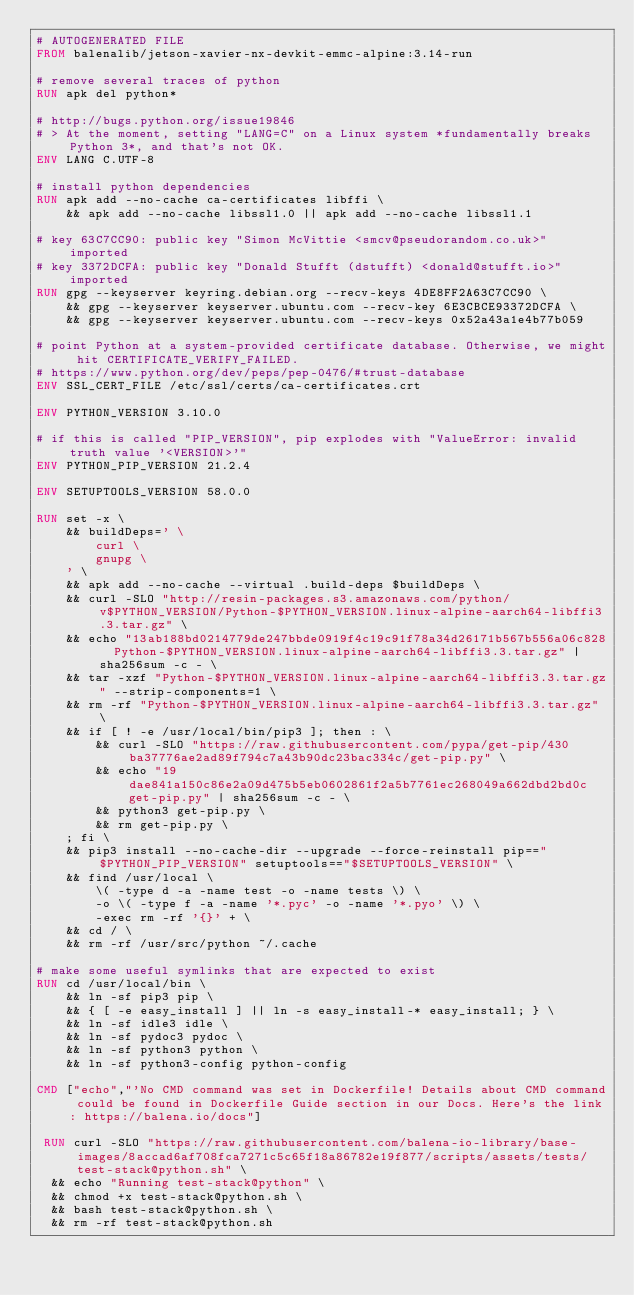Convert code to text. <code><loc_0><loc_0><loc_500><loc_500><_Dockerfile_># AUTOGENERATED FILE
FROM balenalib/jetson-xavier-nx-devkit-emmc-alpine:3.14-run

# remove several traces of python
RUN apk del python*

# http://bugs.python.org/issue19846
# > At the moment, setting "LANG=C" on a Linux system *fundamentally breaks Python 3*, and that's not OK.
ENV LANG C.UTF-8

# install python dependencies
RUN apk add --no-cache ca-certificates libffi \
	&& apk add --no-cache libssl1.0 || apk add --no-cache libssl1.1

# key 63C7CC90: public key "Simon McVittie <smcv@pseudorandom.co.uk>" imported
# key 3372DCFA: public key "Donald Stufft (dstufft) <donald@stufft.io>" imported
RUN gpg --keyserver keyring.debian.org --recv-keys 4DE8FF2A63C7CC90 \
	&& gpg --keyserver keyserver.ubuntu.com --recv-key 6E3CBCE93372DCFA \
	&& gpg --keyserver keyserver.ubuntu.com --recv-keys 0x52a43a1e4b77b059

# point Python at a system-provided certificate database. Otherwise, we might hit CERTIFICATE_VERIFY_FAILED.
# https://www.python.org/dev/peps/pep-0476/#trust-database
ENV SSL_CERT_FILE /etc/ssl/certs/ca-certificates.crt

ENV PYTHON_VERSION 3.10.0

# if this is called "PIP_VERSION", pip explodes with "ValueError: invalid truth value '<VERSION>'"
ENV PYTHON_PIP_VERSION 21.2.4

ENV SETUPTOOLS_VERSION 58.0.0

RUN set -x \
	&& buildDeps=' \
		curl \
		gnupg \
	' \
	&& apk add --no-cache --virtual .build-deps $buildDeps \
	&& curl -SLO "http://resin-packages.s3.amazonaws.com/python/v$PYTHON_VERSION/Python-$PYTHON_VERSION.linux-alpine-aarch64-libffi3.3.tar.gz" \
	&& echo "13ab188bd0214779de247bbde0919f4c19c91f78a34d26171b567b556a06c828  Python-$PYTHON_VERSION.linux-alpine-aarch64-libffi3.3.tar.gz" | sha256sum -c - \
	&& tar -xzf "Python-$PYTHON_VERSION.linux-alpine-aarch64-libffi3.3.tar.gz" --strip-components=1 \
	&& rm -rf "Python-$PYTHON_VERSION.linux-alpine-aarch64-libffi3.3.tar.gz" \
	&& if [ ! -e /usr/local/bin/pip3 ]; then : \
		&& curl -SLO "https://raw.githubusercontent.com/pypa/get-pip/430ba37776ae2ad89f794c7a43b90dc23bac334c/get-pip.py" \
		&& echo "19dae841a150c86e2a09d475b5eb0602861f2a5b7761ec268049a662dbd2bd0c  get-pip.py" | sha256sum -c - \
		&& python3 get-pip.py \
		&& rm get-pip.py \
	; fi \
	&& pip3 install --no-cache-dir --upgrade --force-reinstall pip=="$PYTHON_PIP_VERSION" setuptools=="$SETUPTOOLS_VERSION" \
	&& find /usr/local \
		\( -type d -a -name test -o -name tests \) \
		-o \( -type f -a -name '*.pyc' -o -name '*.pyo' \) \
		-exec rm -rf '{}' + \
	&& cd / \
	&& rm -rf /usr/src/python ~/.cache

# make some useful symlinks that are expected to exist
RUN cd /usr/local/bin \
	&& ln -sf pip3 pip \
	&& { [ -e easy_install ] || ln -s easy_install-* easy_install; } \
	&& ln -sf idle3 idle \
	&& ln -sf pydoc3 pydoc \
	&& ln -sf python3 python \
	&& ln -sf python3-config python-config

CMD ["echo","'No CMD command was set in Dockerfile! Details about CMD command could be found in Dockerfile Guide section in our Docs. Here's the link: https://balena.io/docs"]

 RUN curl -SLO "https://raw.githubusercontent.com/balena-io-library/base-images/8accad6af708fca7271c5c65f18a86782e19f877/scripts/assets/tests/test-stack@python.sh" \
  && echo "Running test-stack@python" \
  && chmod +x test-stack@python.sh \
  && bash test-stack@python.sh \
  && rm -rf test-stack@python.sh 
</code> 